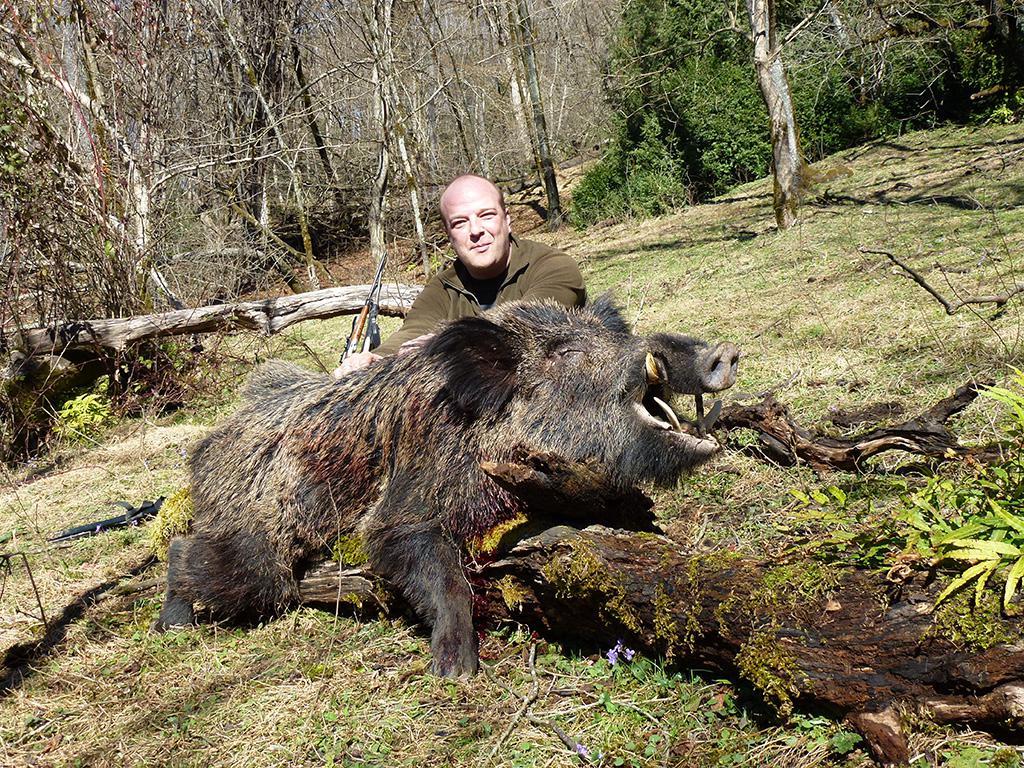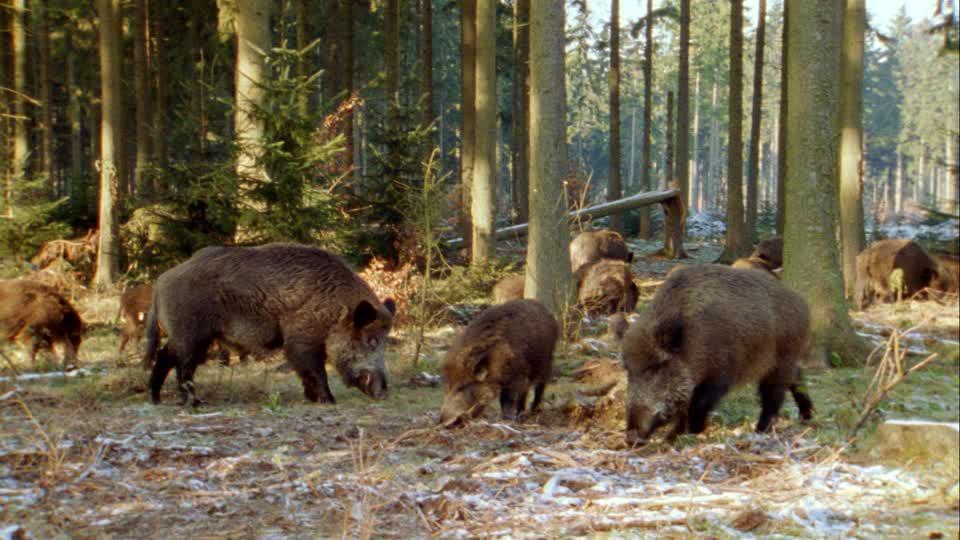The first image is the image on the left, the second image is the image on the right. Assess this claim about the two images: "The group of at least six black and brown boars with a single bore is the middle of the group looking straight forward.". Correct or not? Answer yes or no. No. The first image is the image on the left, the second image is the image on the right. For the images shown, is this caption "There's more than one pig in each picture of the pair" true? Answer yes or no. No. 